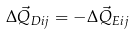Convert formula to latex. <formula><loc_0><loc_0><loc_500><loc_500>\Delta \vec { Q } _ { D i j } = - \Delta \vec { Q } _ { E i j }</formula> 